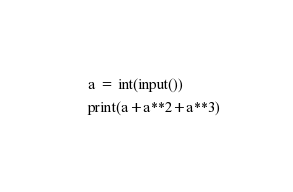Convert code to text. <code><loc_0><loc_0><loc_500><loc_500><_Python_>a = int(input())
print(a+a**2+a**3)</code> 